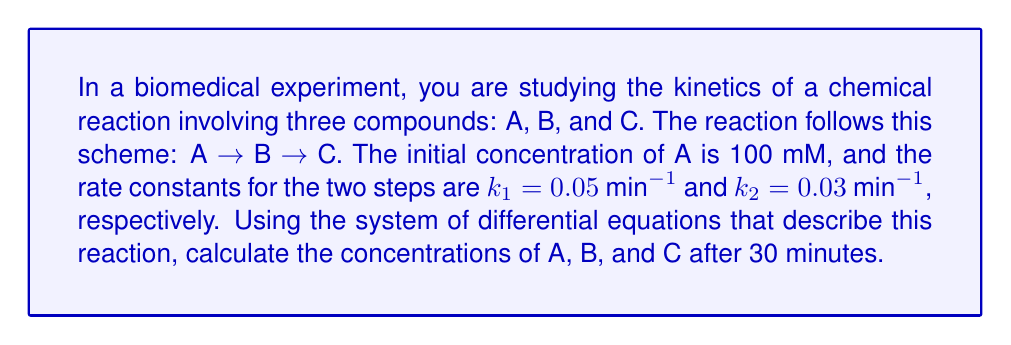Show me your answer to this math problem. To solve this problem, we need to use the system of differential equations that describe the kinetics of consecutive reactions:

$$\frac{d[A]}{dt} = -k_1[A]$$
$$\frac{d[B]}{dt} = k_1[A] - k_2[B]$$
$$\frac{d[C]}{dt} = k_2[B]$$

Where [A], [B], and [C] are the concentrations of compounds A, B, and C, respectively.

For consecutive first-order reactions, we can use the following analytical solutions:

$$[A] = [A]_0 e^{-k_1t}$$
$$[B] = \frac{k_1[A]_0}{k_2-k_1}(e^{-k_1t} - e^{-k_2t})$$
$$[C] = [A]_0(1 + \frac{k_1e^{-k_2t} - k_2e^{-k_1t}}{k_2-k_1})$$

Where $[A]_0$ is the initial concentration of A.

Given:
- $[A]_0 = 100$ mM
- $k_1 = 0.05$ $min^{-1}$
- $k_2 = 0.03$ $min^{-1}$
- $t = 30$ minutes

Let's calculate the concentrations:

1. Concentration of A:
   $$[A] = 100 e^{-0.05 \times 30} = 22.31\text{ mM}$$

2. Concentration of B:
   $$[B] = \frac{0.05 \times 100}{0.03-0.05}(e^{-0.05 \times 30} - e^{-0.03 \times 30})$$
   $$= -250(0.2231 - 0.4066) = 45.88\text{ mM}$$

3. Concentration of C:
   $$[C] = 100(1 + \frac{0.05e^{-0.03 \times 30} - 0.03e^{-0.05 \times 30}}{0.03-0.05})$$
   $$= 100(1 + \frac{0.05 \times 0.4066 - 0.03 \times 0.2231}{-0.02})$$
   $$= 100(1 - 0.6819) = 31.81\text{ mM}$$
Answer: After 30 minutes:
[A] = 22.31 mM
[B] = 45.88 mM
[C] = 31.81 mM 